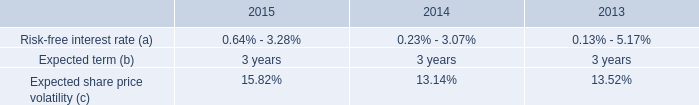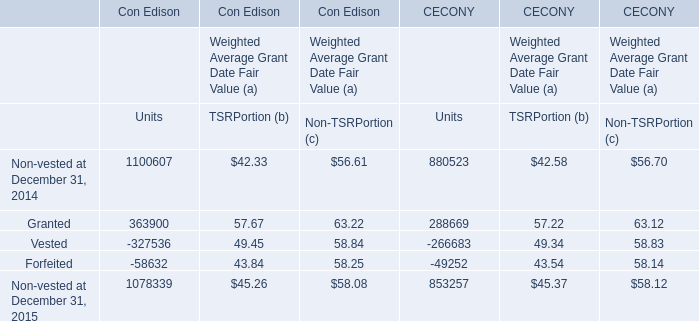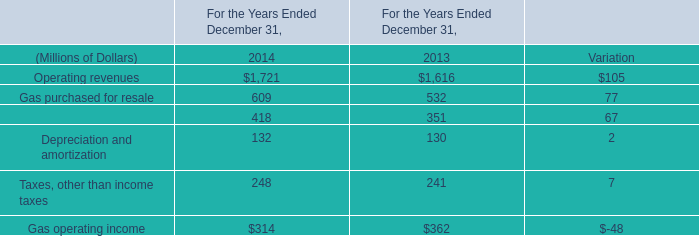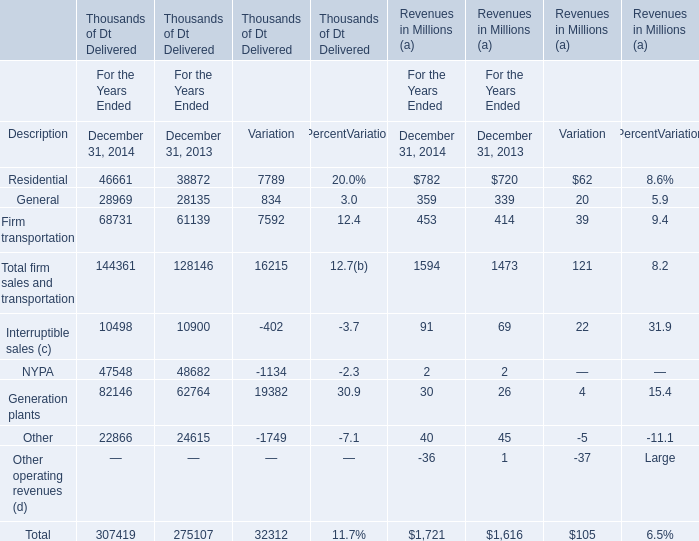What is the percentage of Gas operating income in relation to the total in 2014 ? (in million) 
Computations: (314 / 1721)
Answer: 0.18245. 